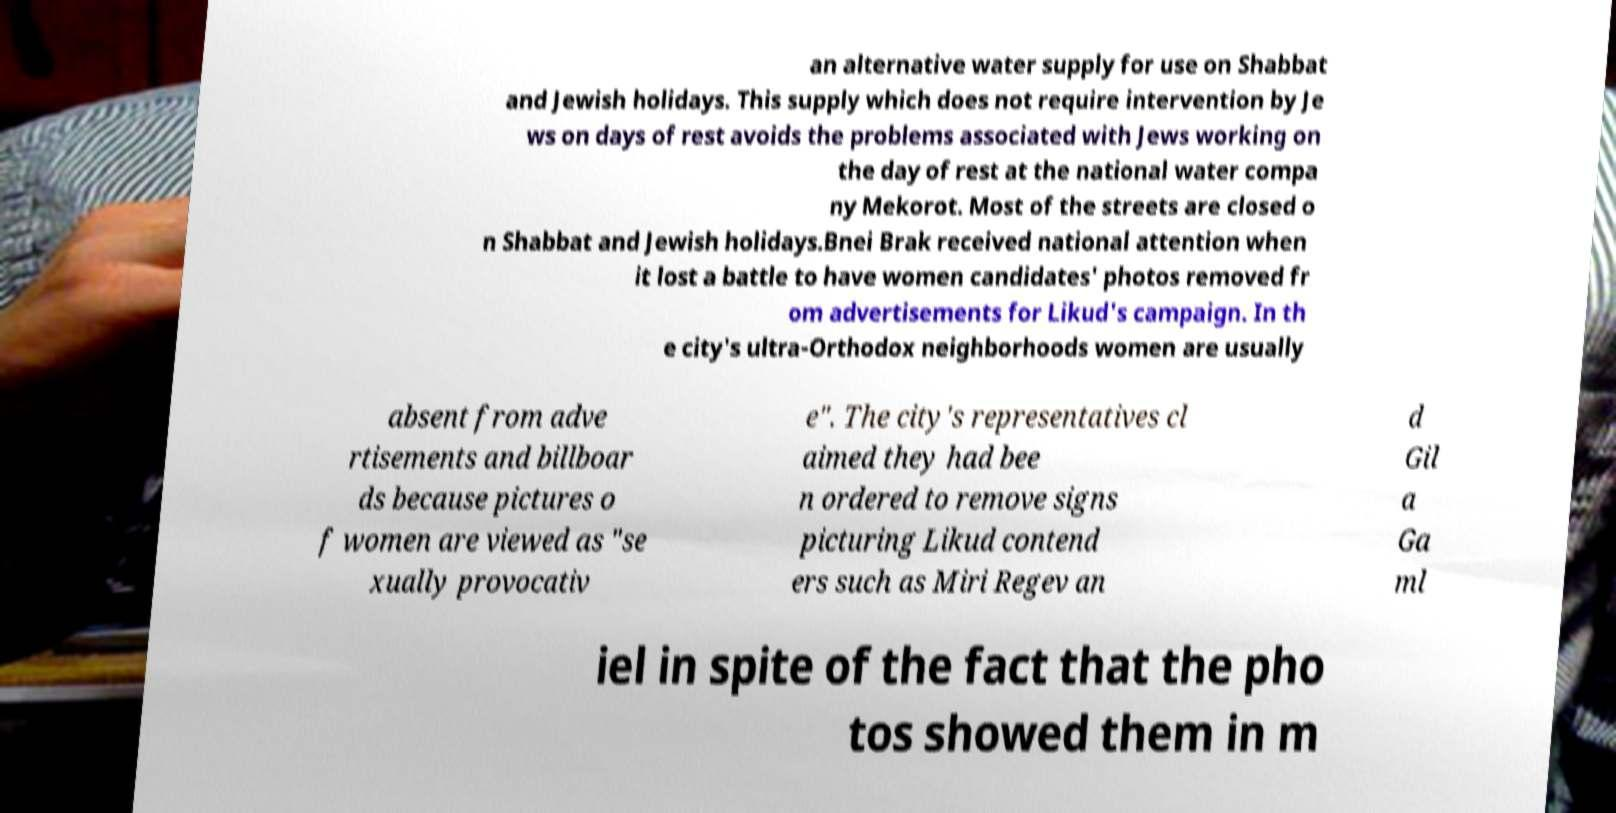Please identify and transcribe the text found in this image. an alternative water supply for use on Shabbat and Jewish holidays. This supply which does not require intervention by Je ws on days of rest avoids the problems associated with Jews working on the day of rest at the national water compa ny Mekorot. Most of the streets are closed o n Shabbat and Jewish holidays.Bnei Brak received national attention when it lost a battle to have women candidates' photos removed fr om advertisements for Likud's campaign. In th e city's ultra-Orthodox neighborhoods women are usually absent from adve rtisements and billboar ds because pictures o f women are viewed as "se xually provocativ e". The city's representatives cl aimed they had bee n ordered to remove signs picturing Likud contend ers such as Miri Regev an d Gil a Ga ml iel in spite of the fact that the pho tos showed them in m 